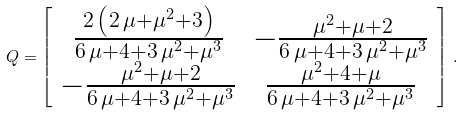Convert formula to latex. <formula><loc_0><loc_0><loc_500><loc_500>Q = \left [ \begin{array} { c c } { \frac { 2 \, \left ( 2 \, \mu + { \mu } ^ { 2 } + 3 \right ) } { 6 \, \mu + 4 + 3 \, { \mu } ^ { 2 } + { \mu } ^ { 3 } } } & - { \frac { { \mu } ^ { 2 } + \mu + 2 } { 6 \, \mu + 4 + 3 \, { \mu } ^ { 2 } + { \mu } ^ { 3 } } } \\ - { \frac { { \mu } ^ { 2 } + \mu + 2 } { 6 \, \mu + 4 + 3 \, { \mu } ^ { 2 } + { \mu } ^ { 3 } } } & { \frac { { \mu } ^ { 2 } + 4 + \mu } { 6 \, \mu + 4 + 3 \, { \mu } ^ { 2 } + { \mu } ^ { 3 } } } \\ \end{array} \right ] \, .</formula> 